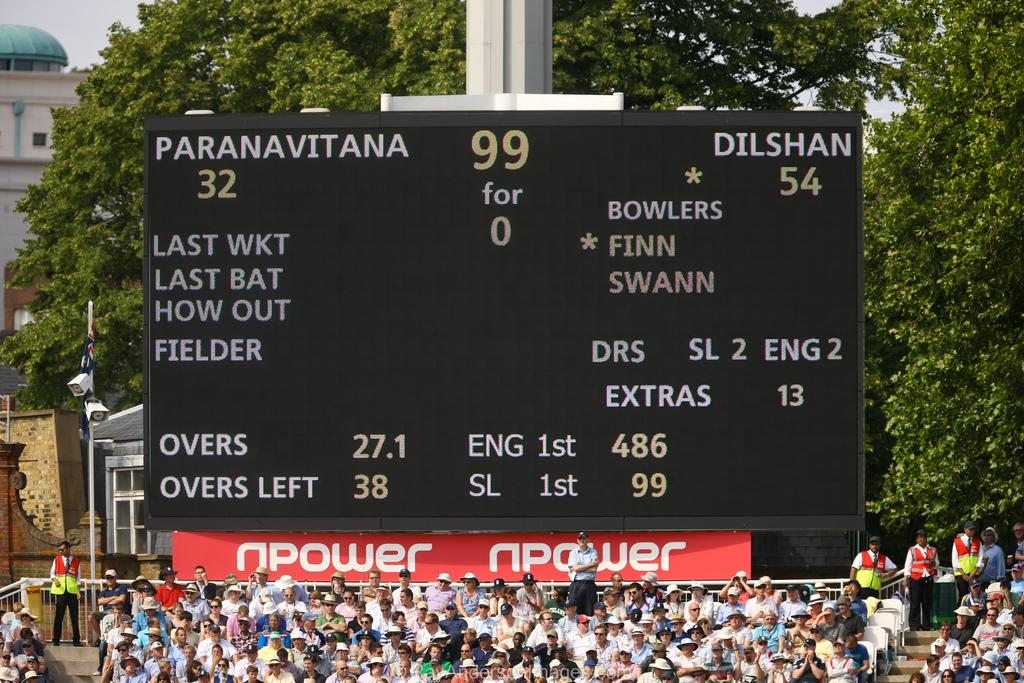<image>
Share a concise interpretation of the image provided. A large display screen that has the scores of Paranavitana 32 to Dilshan 54 